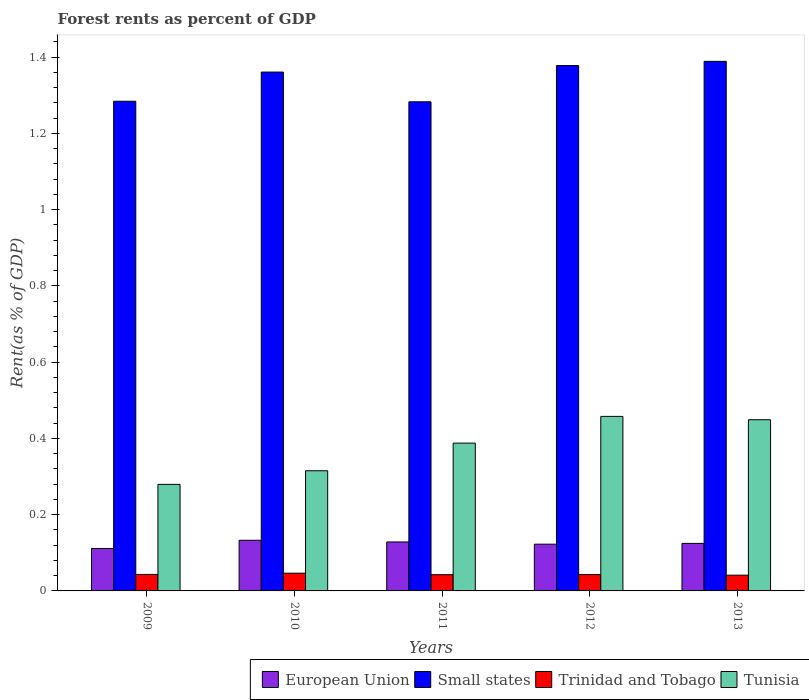How many different coloured bars are there?
Ensure brevity in your answer.  4. How many groups of bars are there?
Your response must be concise. 5. Are the number of bars per tick equal to the number of legend labels?
Provide a succinct answer. Yes. Are the number of bars on each tick of the X-axis equal?
Your response must be concise. Yes. How many bars are there on the 2nd tick from the left?
Ensure brevity in your answer.  4. In how many cases, is the number of bars for a given year not equal to the number of legend labels?
Your response must be concise. 0. What is the forest rent in Trinidad and Tobago in 2010?
Make the answer very short. 0.05. Across all years, what is the maximum forest rent in European Union?
Ensure brevity in your answer.  0.13. Across all years, what is the minimum forest rent in Tunisia?
Offer a very short reply. 0.28. In which year was the forest rent in Tunisia maximum?
Provide a succinct answer. 2012. What is the total forest rent in Tunisia in the graph?
Your answer should be compact. 1.89. What is the difference between the forest rent in Tunisia in 2010 and that in 2013?
Provide a short and direct response. -0.13. What is the difference between the forest rent in Small states in 2011 and the forest rent in European Union in 2010?
Your answer should be very brief. 1.15. What is the average forest rent in Trinidad and Tobago per year?
Keep it short and to the point. 0.04. In the year 2013, what is the difference between the forest rent in Trinidad and Tobago and forest rent in Small states?
Make the answer very short. -1.35. In how many years, is the forest rent in European Union greater than 0.6400000000000001 %?
Your answer should be compact. 0. What is the ratio of the forest rent in Small states in 2009 to that in 2010?
Offer a terse response. 0.94. Is the forest rent in Trinidad and Tobago in 2010 less than that in 2011?
Keep it short and to the point. No. What is the difference between the highest and the second highest forest rent in Trinidad and Tobago?
Provide a succinct answer. 0. What is the difference between the highest and the lowest forest rent in Tunisia?
Your answer should be very brief. 0.18. Is it the case that in every year, the sum of the forest rent in Small states and forest rent in Trinidad and Tobago is greater than the sum of forest rent in Tunisia and forest rent in European Union?
Offer a very short reply. No. What does the 4th bar from the right in 2010 represents?
Ensure brevity in your answer.  European Union. Is it the case that in every year, the sum of the forest rent in Small states and forest rent in Tunisia is greater than the forest rent in Trinidad and Tobago?
Make the answer very short. Yes. Does the graph contain grids?
Give a very brief answer. No. What is the title of the graph?
Provide a succinct answer. Forest rents as percent of GDP. Does "Estonia" appear as one of the legend labels in the graph?
Provide a short and direct response. No. What is the label or title of the X-axis?
Your answer should be compact. Years. What is the label or title of the Y-axis?
Offer a terse response. Rent(as % of GDP). What is the Rent(as % of GDP) in European Union in 2009?
Ensure brevity in your answer.  0.11. What is the Rent(as % of GDP) in Small states in 2009?
Provide a succinct answer. 1.28. What is the Rent(as % of GDP) of Trinidad and Tobago in 2009?
Provide a succinct answer. 0.04. What is the Rent(as % of GDP) in Tunisia in 2009?
Offer a very short reply. 0.28. What is the Rent(as % of GDP) in European Union in 2010?
Offer a very short reply. 0.13. What is the Rent(as % of GDP) in Small states in 2010?
Provide a short and direct response. 1.36. What is the Rent(as % of GDP) in Trinidad and Tobago in 2010?
Ensure brevity in your answer.  0.05. What is the Rent(as % of GDP) in Tunisia in 2010?
Provide a succinct answer. 0.32. What is the Rent(as % of GDP) of European Union in 2011?
Your response must be concise. 0.13. What is the Rent(as % of GDP) in Small states in 2011?
Offer a terse response. 1.28. What is the Rent(as % of GDP) in Trinidad and Tobago in 2011?
Provide a short and direct response. 0.04. What is the Rent(as % of GDP) in Tunisia in 2011?
Offer a terse response. 0.39. What is the Rent(as % of GDP) in European Union in 2012?
Your answer should be compact. 0.12. What is the Rent(as % of GDP) in Small states in 2012?
Give a very brief answer. 1.38. What is the Rent(as % of GDP) of Trinidad and Tobago in 2012?
Ensure brevity in your answer.  0.04. What is the Rent(as % of GDP) of Tunisia in 2012?
Keep it short and to the point. 0.46. What is the Rent(as % of GDP) of European Union in 2013?
Give a very brief answer. 0.12. What is the Rent(as % of GDP) in Small states in 2013?
Your response must be concise. 1.39. What is the Rent(as % of GDP) of Trinidad and Tobago in 2013?
Your response must be concise. 0.04. What is the Rent(as % of GDP) in Tunisia in 2013?
Provide a succinct answer. 0.45. Across all years, what is the maximum Rent(as % of GDP) in European Union?
Your response must be concise. 0.13. Across all years, what is the maximum Rent(as % of GDP) of Small states?
Keep it short and to the point. 1.39. Across all years, what is the maximum Rent(as % of GDP) of Trinidad and Tobago?
Offer a terse response. 0.05. Across all years, what is the maximum Rent(as % of GDP) in Tunisia?
Offer a very short reply. 0.46. Across all years, what is the minimum Rent(as % of GDP) in European Union?
Give a very brief answer. 0.11. Across all years, what is the minimum Rent(as % of GDP) in Small states?
Your response must be concise. 1.28. Across all years, what is the minimum Rent(as % of GDP) of Trinidad and Tobago?
Offer a terse response. 0.04. Across all years, what is the minimum Rent(as % of GDP) in Tunisia?
Provide a succinct answer. 0.28. What is the total Rent(as % of GDP) of European Union in the graph?
Your answer should be compact. 0.62. What is the total Rent(as % of GDP) in Small states in the graph?
Offer a very short reply. 6.7. What is the total Rent(as % of GDP) of Trinidad and Tobago in the graph?
Your response must be concise. 0.22. What is the total Rent(as % of GDP) in Tunisia in the graph?
Give a very brief answer. 1.89. What is the difference between the Rent(as % of GDP) in European Union in 2009 and that in 2010?
Your answer should be compact. -0.02. What is the difference between the Rent(as % of GDP) of Small states in 2009 and that in 2010?
Make the answer very short. -0.08. What is the difference between the Rent(as % of GDP) of Trinidad and Tobago in 2009 and that in 2010?
Offer a very short reply. -0. What is the difference between the Rent(as % of GDP) of Tunisia in 2009 and that in 2010?
Your answer should be very brief. -0.04. What is the difference between the Rent(as % of GDP) in European Union in 2009 and that in 2011?
Provide a short and direct response. -0.02. What is the difference between the Rent(as % of GDP) of Small states in 2009 and that in 2011?
Provide a short and direct response. 0. What is the difference between the Rent(as % of GDP) of Trinidad and Tobago in 2009 and that in 2011?
Make the answer very short. 0. What is the difference between the Rent(as % of GDP) in Tunisia in 2009 and that in 2011?
Offer a terse response. -0.11. What is the difference between the Rent(as % of GDP) of European Union in 2009 and that in 2012?
Ensure brevity in your answer.  -0.01. What is the difference between the Rent(as % of GDP) in Small states in 2009 and that in 2012?
Your answer should be compact. -0.09. What is the difference between the Rent(as % of GDP) of Tunisia in 2009 and that in 2012?
Your answer should be compact. -0.18. What is the difference between the Rent(as % of GDP) of European Union in 2009 and that in 2013?
Offer a terse response. -0.01. What is the difference between the Rent(as % of GDP) of Small states in 2009 and that in 2013?
Ensure brevity in your answer.  -0.1. What is the difference between the Rent(as % of GDP) of Trinidad and Tobago in 2009 and that in 2013?
Your response must be concise. 0. What is the difference between the Rent(as % of GDP) of Tunisia in 2009 and that in 2013?
Provide a short and direct response. -0.17. What is the difference between the Rent(as % of GDP) of European Union in 2010 and that in 2011?
Ensure brevity in your answer.  0. What is the difference between the Rent(as % of GDP) in Small states in 2010 and that in 2011?
Make the answer very short. 0.08. What is the difference between the Rent(as % of GDP) of Trinidad and Tobago in 2010 and that in 2011?
Your answer should be very brief. 0. What is the difference between the Rent(as % of GDP) in Tunisia in 2010 and that in 2011?
Ensure brevity in your answer.  -0.07. What is the difference between the Rent(as % of GDP) of European Union in 2010 and that in 2012?
Ensure brevity in your answer.  0.01. What is the difference between the Rent(as % of GDP) in Small states in 2010 and that in 2012?
Offer a terse response. -0.02. What is the difference between the Rent(as % of GDP) in Trinidad and Tobago in 2010 and that in 2012?
Offer a terse response. 0. What is the difference between the Rent(as % of GDP) in Tunisia in 2010 and that in 2012?
Provide a succinct answer. -0.14. What is the difference between the Rent(as % of GDP) of European Union in 2010 and that in 2013?
Give a very brief answer. 0.01. What is the difference between the Rent(as % of GDP) in Small states in 2010 and that in 2013?
Provide a succinct answer. -0.03. What is the difference between the Rent(as % of GDP) of Trinidad and Tobago in 2010 and that in 2013?
Give a very brief answer. 0.01. What is the difference between the Rent(as % of GDP) in Tunisia in 2010 and that in 2013?
Give a very brief answer. -0.13. What is the difference between the Rent(as % of GDP) in European Union in 2011 and that in 2012?
Offer a terse response. 0.01. What is the difference between the Rent(as % of GDP) of Small states in 2011 and that in 2012?
Your answer should be compact. -0.1. What is the difference between the Rent(as % of GDP) in Trinidad and Tobago in 2011 and that in 2012?
Offer a terse response. -0. What is the difference between the Rent(as % of GDP) in Tunisia in 2011 and that in 2012?
Make the answer very short. -0.07. What is the difference between the Rent(as % of GDP) of European Union in 2011 and that in 2013?
Your answer should be very brief. 0. What is the difference between the Rent(as % of GDP) of Small states in 2011 and that in 2013?
Keep it short and to the point. -0.11. What is the difference between the Rent(as % of GDP) in Trinidad and Tobago in 2011 and that in 2013?
Ensure brevity in your answer.  0. What is the difference between the Rent(as % of GDP) of Tunisia in 2011 and that in 2013?
Provide a short and direct response. -0.06. What is the difference between the Rent(as % of GDP) in European Union in 2012 and that in 2013?
Offer a very short reply. -0. What is the difference between the Rent(as % of GDP) of Small states in 2012 and that in 2013?
Provide a short and direct response. -0.01. What is the difference between the Rent(as % of GDP) of Trinidad and Tobago in 2012 and that in 2013?
Make the answer very short. 0. What is the difference between the Rent(as % of GDP) in Tunisia in 2012 and that in 2013?
Give a very brief answer. 0.01. What is the difference between the Rent(as % of GDP) of European Union in 2009 and the Rent(as % of GDP) of Small states in 2010?
Give a very brief answer. -1.25. What is the difference between the Rent(as % of GDP) of European Union in 2009 and the Rent(as % of GDP) of Trinidad and Tobago in 2010?
Give a very brief answer. 0.06. What is the difference between the Rent(as % of GDP) of European Union in 2009 and the Rent(as % of GDP) of Tunisia in 2010?
Your answer should be compact. -0.2. What is the difference between the Rent(as % of GDP) of Small states in 2009 and the Rent(as % of GDP) of Trinidad and Tobago in 2010?
Give a very brief answer. 1.24. What is the difference between the Rent(as % of GDP) of Small states in 2009 and the Rent(as % of GDP) of Tunisia in 2010?
Provide a succinct answer. 0.97. What is the difference between the Rent(as % of GDP) in Trinidad and Tobago in 2009 and the Rent(as % of GDP) in Tunisia in 2010?
Provide a succinct answer. -0.27. What is the difference between the Rent(as % of GDP) of European Union in 2009 and the Rent(as % of GDP) of Small states in 2011?
Your response must be concise. -1.17. What is the difference between the Rent(as % of GDP) in European Union in 2009 and the Rent(as % of GDP) in Trinidad and Tobago in 2011?
Make the answer very short. 0.07. What is the difference between the Rent(as % of GDP) of European Union in 2009 and the Rent(as % of GDP) of Tunisia in 2011?
Ensure brevity in your answer.  -0.28. What is the difference between the Rent(as % of GDP) in Small states in 2009 and the Rent(as % of GDP) in Trinidad and Tobago in 2011?
Provide a short and direct response. 1.24. What is the difference between the Rent(as % of GDP) in Small states in 2009 and the Rent(as % of GDP) in Tunisia in 2011?
Ensure brevity in your answer.  0.9. What is the difference between the Rent(as % of GDP) of Trinidad and Tobago in 2009 and the Rent(as % of GDP) of Tunisia in 2011?
Provide a succinct answer. -0.34. What is the difference between the Rent(as % of GDP) in European Union in 2009 and the Rent(as % of GDP) in Small states in 2012?
Your answer should be compact. -1.27. What is the difference between the Rent(as % of GDP) in European Union in 2009 and the Rent(as % of GDP) in Trinidad and Tobago in 2012?
Your response must be concise. 0.07. What is the difference between the Rent(as % of GDP) of European Union in 2009 and the Rent(as % of GDP) of Tunisia in 2012?
Provide a succinct answer. -0.35. What is the difference between the Rent(as % of GDP) in Small states in 2009 and the Rent(as % of GDP) in Trinidad and Tobago in 2012?
Offer a terse response. 1.24. What is the difference between the Rent(as % of GDP) in Small states in 2009 and the Rent(as % of GDP) in Tunisia in 2012?
Ensure brevity in your answer.  0.83. What is the difference between the Rent(as % of GDP) in Trinidad and Tobago in 2009 and the Rent(as % of GDP) in Tunisia in 2012?
Make the answer very short. -0.41. What is the difference between the Rent(as % of GDP) of European Union in 2009 and the Rent(as % of GDP) of Small states in 2013?
Make the answer very short. -1.28. What is the difference between the Rent(as % of GDP) of European Union in 2009 and the Rent(as % of GDP) of Trinidad and Tobago in 2013?
Provide a succinct answer. 0.07. What is the difference between the Rent(as % of GDP) in European Union in 2009 and the Rent(as % of GDP) in Tunisia in 2013?
Provide a succinct answer. -0.34. What is the difference between the Rent(as % of GDP) in Small states in 2009 and the Rent(as % of GDP) in Trinidad and Tobago in 2013?
Provide a succinct answer. 1.24. What is the difference between the Rent(as % of GDP) of Small states in 2009 and the Rent(as % of GDP) of Tunisia in 2013?
Your answer should be very brief. 0.84. What is the difference between the Rent(as % of GDP) of Trinidad and Tobago in 2009 and the Rent(as % of GDP) of Tunisia in 2013?
Ensure brevity in your answer.  -0.41. What is the difference between the Rent(as % of GDP) of European Union in 2010 and the Rent(as % of GDP) of Small states in 2011?
Keep it short and to the point. -1.15. What is the difference between the Rent(as % of GDP) in European Union in 2010 and the Rent(as % of GDP) in Trinidad and Tobago in 2011?
Keep it short and to the point. 0.09. What is the difference between the Rent(as % of GDP) of European Union in 2010 and the Rent(as % of GDP) of Tunisia in 2011?
Your answer should be very brief. -0.25. What is the difference between the Rent(as % of GDP) of Small states in 2010 and the Rent(as % of GDP) of Trinidad and Tobago in 2011?
Your answer should be very brief. 1.32. What is the difference between the Rent(as % of GDP) in Small states in 2010 and the Rent(as % of GDP) in Tunisia in 2011?
Your answer should be very brief. 0.97. What is the difference between the Rent(as % of GDP) in Trinidad and Tobago in 2010 and the Rent(as % of GDP) in Tunisia in 2011?
Make the answer very short. -0.34. What is the difference between the Rent(as % of GDP) of European Union in 2010 and the Rent(as % of GDP) of Small states in 2012?
Make the answer very short. -1.25. What is the difference between the Rent(as % of GDP) of European Union in 2010 and the Rent(as % of GDP) of Trinidad and Tobago in 2012?
Offer a terse response. 0.09. What is the difference between the Rent(as % of GDP) of European Union in 2010 and the Rent(as % of GDP) of Tunisia in 2012?
Provide a short and direct response. -0.32. What is the difference between the Rent(as % of GDP) in Small states in 2010 and the Rent(as % of GDP) in Trinidad and Tobago in 2012?
Give a very brief answer. 1.32. What is the difference between the Rent(as % of GDP) in Small states in 2010 and the Rent(as % of GDP) in Tunisia in 2012?
Give a very brief answer. 0.9. What is the difference between the Rent(as % of GDP) in Trinidad and Tobago in 2010 and the Rent(as % of GDP) in Tunisia in 2012?
Your answer should be compact. -0.41. What is the difference between the Rent(as % of GDP) in European Union in 2010 and the Rent(as % of GDP) in Small states in 2013?
Keep it short and to the point. -1.26. What is the difference between the Rent(as % of GDP) in European Union in 2010 and the Rent(as % of GDP) in Trinidad and Tobago in 2013?
Keep it short and to the point. 0.09. What is the difference between the Rent(as % of GDP) in European Union in 2010 and the Rent(as % of GDP) in Tunisia in 2013?
Make the answer very short. -0.32. What is the difference between the Rent(as % of GDP) of Small states in 2010 and the Rent(as % of GDP) of Trinidad and Tobago in 2013?
Your answer should be compact. 1.32. What is the difference between the Rent(as % of GDP) of Small states in 2010 and the Rent(as % of GDP) of Tunisia in 2013?
Your response must be concise. 0.91. What is the difference between the Rent(as % of GDP) in Trinidad and Tobago in 2010 and the Rent(as % of GDP) in Tunisia in 2013?
Offer a very short reply. -0.4. What is the difference between the Rent(as % of GDP) in European Union in 2011 and the Rent(as % of GDP) in Small states in 2012?
Your response must be concise. -1.25. What is the difference between the Rent(as % of GDP) in European Union in 2011 and the Rent(as % of GDP) in Trinidad and Tobago in 2012?
Provide a short and direct response. 0.09. What is the difference between the Rent(as % of GDP) in European Union in 2011 and the Rent(as % of GDP) in Tunisia in 2012?
Give a very brief answer. -0.33. What is the difference between the Rent(as % of GDP) in Small states in 2011 and the Rent(as % of GDP) in Trinidad and Tobago in 2012?
Make the answer very short. 1.24. What is the difference between the Rent(as % of GDP) in Small states in 2011 and the Rent(as % of GDP) in Tunisia in 2012?
Make the answer very short. 0.83. What is the difference between the Rent(as % of GDP) of Trinidad and Tobago in 2011 and the Rent(as % of GDP) of Tunisia in 2012?
Your response must be concise. -0.42. What is the difference between the Rent(as % of GDP) in European Union in 2011 and the Rent(as % of GDP) in Small states in 2013?
Keep it short and to the point. -1.26. What is the difference between the Rent(as % of GDP) of European Union in 2011 and the Rent(as % of GDP) of Trinidad and Tobago in 2013?
Provide a short and direct response. 0.09. What is the difference between the Rent(as % of GDP) of European Union in 2011 and the Rent(as % of GDP) of Tunisia in 2013?
Make the answer very short. -0.32. What is the difference between the Rent(as % of GDP) of Small states in 2011 and the Rent(as % of GDP) of Trinidad and Tobago in 2013?
Ensure brevity in your answer.  1.24. What is the difference between the Rent(as % of GDP) in Small states in 2011 and the Rent(as % of GDP) in Tunisia in 2013?
Offer a very short reply. 0.83. What is the difference between the Rent(as % of GDP) of Trinidad and Tobago in 2011 and the Rent(as % of GDP) of Tunisia in 2013?
Give a very brief answer. -0.41. What is the difference between the Rent(as % of GDP) of European Union in 2012 and the Rent(as % of GDP) of Small states in 2013?
Give a very brief answer. -1.27. What is the difference between the Rent(as % of GDP) of European Union in 2012 and the Rent(as % of GDP) of Trinidad and Tobago in 2013?
Provide a succinct answer. 0.08. What is the difference between the Rent(as % of GDP) in European Union in 2012 and the Rent(as % of GDP) in Tunisia in 2013?
Make the answer very short. -0.33. What is the difference between the Rent(as % of GDP) in Small states in 2012 and the Rent(as % of GDP) in Trinidad and Tobago in 2013?
Make the answer very short. 1.34. What is the difference between the Rent(as % of GDP) of Small states in 2012 and the Rent(as % of GDP) of Tunisia in 2013?
Offer a terse response. 0.93. What is the difference between the Rent(as % of GDP) in Trinidad and Tobago in 2012 and the Rent(as % of GDP) in Tunisia in 2013?
Offer a very short reply. -0.41. What is the average Rent(as % of GDP) in European Union per year?
Keep it short and to the point. 0.12. What is the average Rent(as % of GDP) of Small states per year?
Your answer should be compact. 1.34. What is the average Rent(as % of GDP) of Trinidad and Tobago per year?
Make the answer very short. 0.04. What is the average Rent(as % of GDP) of Tunisia per year?
Offer a very short reply. 0.38. In the year 2009, what is the difference between the Rent(as % of GDP) in European Union and Rent(as % of GDP) in Small states?
Offer a terse response. -1.17. In the year 2009, what is the difference between the Rent(as % of GDP) in European Union and Rent(as % of GDP) in Trinidad and Tobago?
Provide a short and direct response. 0.07. In the year 2009, what is the difference between the Rent(as % of GDP) in European Union and Rent(as % of GDP) in Tunisia?
Your answer should be very brief. -0.17. In the year 2009, what is the difference between the Rent(as % of GDP) in Small states and Rent(as % of GDP) in Trinidad and Tobago?
Your answer should be compact. 1.24. In the year 2009, what is the difference between the Rent(as % of GDP) of Trinidad and Tobago and Rent(as % of GDP) of Tunisia?
Your response must be concise. -0.24. In the year 2010, what is the difference between the Rent(as % of GDP) in European Union and Rent(as % of GDP) in Small states?
Keep it short and to the point. -1.23. In the year 2010, what is the difference between the Rent(as % of GDP) in European Union and Rent(as % of GDP) in Trinidad and Tobago?
Provide a succinct answer. 0.09. In the year 2010, what is the difference between the Rent(as % of GDP) of European Union and Rent(as % of GDP) of Tunisia?
Offer a very short reply. -0.18. In the year 2010, what is the difference between the Rent(as % of GDP) in Small states and Rent(as % of GDP) in Trinidad and Tobago?
Provide a short and direct response. 1.31. In the year 2010, what is the difference between the Rent(as % of GDP) in Small states and Rent(as % of GDP) in Tunisia?
Your answer should be compact. 1.05. In the year 2010, what is the difference between the Rent(as % of GDP) in Trinidad and Tobago and Rent(as % of GDP) in Tunisia?
Provide a succinct answer. -0.27. In the year 2011, what is the difference between the Rent(as % of GDP) of European Union and Rent(as % of GDP) of Small states?
Your response must be concise. -1.15. In the year 2011, what is the difference between the Rent(as % of GDP) of European Union and Rent(as % of GDP) of Trinidad and Tobago?
Give a very brief answer. 0.09. In the year 2011, what is the difference between the Rent(as % of GDP) in European Union and Rent(as % of GDP) in Tunisia?
Ensure brevity in your answer.  -0.26. In the year 2011, what is the difference between the Rent(as % of GDP) in Small states and Rent(as % of GDP) in Trinidad and Tobago?
Provide a succinct answer. 1.24. In the year 2011, what is the difference between the Rent(as % of GDP) in Small states and Rent(as % of GDP) in Tunisia?
Offer a very short reply. 0.9. In the year 2011, what is the difference between the Rent(as % of GDP) in Trinidad and Tobago and Rent(as % of GDP) in Tunisia?
Your response must be concise. -0.35. In the year 2012, what is the difference between the Rent(as % of GDP) in European Union and Rent(as % of GDP) in Small states?
Your response must be concise. -1.26. In the year 2012, what is the difference between the Rent(as % of GDP) of European Union and Rent(as % of GDP) of Trinidad and Tobago?
Your response must be concise. 0.08. In the year 2012, what is the difference between the Rent(as % of GDP) in European Union and Rent(as % of GDP) in Tunisia?
Your answer should be very brief. -0.34. In the year 2012, what is the difference between the Rent(as % of GDP) in Small states and Rent(as % of GDP) in Trinidad and Tobago?
Your answer should be compact. 1.34. In the year 2012, what is the difference between the Rent(as % of GDP) in Small states and Rent(as % of GDP) in Tunisia?
Offer a very short reply. 0.92. In the year 2012, what is the difference between the Rent(as % of GDP) in Trinidad and Tobago and Rent(as % of GDP) in Tunisia?
Your answer should be very brief. -0.41. In the year 2013, what is the difference between the Rent(as % of GDP) in European Union and Rent(as % of GDP) in Small states?
Make the answer very short. -1.26. In the year 2013, what is the difference between the Rent(as % of GDP) in European Union and Rent(as % of GDP) in Trinidad and Tobago?
Keep it short and to the point. 0.08. In the year 2013, what is the difference between the Rent(as % of GDP) of European Union and Rent(as % of GDP) of Tunisia?
Your answer should be very brief. -0.32. In the year 2013, what is the difference between the Rent(as % of GDP) in Small states and Rent(as % of GDP) in Trinidad and Tobago?
Your response must be concise. 1.35. In the year 2013, what is the difference between the Rent(as % of GDP) in Small states and Rent(as % of GDP) in Tunisia?
Provide a short and direct response. 0.94. In the year 2013, what is the difference between the Rent(as % of GDP) in Trinidad and Tobago and Rent(as % of GDP) in Tunisia?
Make the answer very short. -0.41. What is the ratio of the Rent(as % of GDP) of European Union in 2009 to that in 2010?
Offer a terse response. 0.84. What is the ratio of the Rent(as % of GDP) in Small states in 2009 to that in 2010?
Ensure brevity in your answer.  0.94. What is the ratio of the Rent(as % of GDP) of Trinidad and Tobago in 2009 to that in 2010?
Your response must be concise. 0.93. What is the ratio of the Rent(as % of GDP) of Tunisia in 2009 to that in 2010?
Offer a terse response. 0.89. What is the ratio of the Rent(as % of GDP) of European Union in 2009 to that in 2011?
Ensure brevity in your answer.  0.87. What is the ratio of the Rent(as % of GDP) in Trinidad and Tobago in 2009 to that in 2011?
Ensure brevity in your answer.  1.02. What is the ratio of the Rent(as % of GDP) in Tunisia in 2009 to that in 2011?
Offer a terse response. 0.72. What is the ratio of the Rent(as % of GDP) of European Union in 2009 to that in 2012?
Ensure brevity in your answer.  0.91. What is the ratio of the Rent(as % of GDP) of Small states in 2009 to that in 2012?
Make the answer very short. 0.93. What is the ratio of the Rent(as % of GDP) in Trinidad and Tobago in 2009 to that in 2012?
Offer a terse response. 1.01. What is the ratio of the Rent(as % of GDP) of Tunisia in 2009 to that in 2012?
Offer a terse response. 0.61. What is the ratio of the Rent(as % of GDP) in European Union in 2009 to that in 2013?
Your answer should be very brief. 0.89. What is the ratio of the Rent(as % of GDP) in Small states in 2009 to that in 2013?
Give a very brief answer. 0.92. What is the ratio of the Rent(as % of GDP) of Trinidad and Tobago in 2009 to that in 2013?
Provide a short and direct response. 1.05. What is the ratio of the Rent(as % of GDP) of Tunisia in 2009 to that in 2013?
Your answer should be compact. 0.62. What is the ratio of the Rent(as % of GDP) in European Union in 2010 to that in 2011?
Provide a short and direct response. 1.03. What is the ratio of the Rent(as % of GDP) of Small states in 2010 to that in 2011?
Provide a short and direct response. 1.06. What is the ratio of the Rent(as % of GDP) in Trinidad and Tobago in 2010 to that in 2011?
Ensure brevity in your answer.  1.09. What is the ratio of the Rent(as % of GDP) in Tunisia in 2010 to that in 2011?
Your answer should be compact. 0.81. What is the ratio of the Rent(as % of GDP) in European Union in 2010 to that in 2012?
Make the answer very short. 1.08. What is the ratio of the Rent(as % of GDP) in Small states in 2010 to that in 2012?
Keep it short and to the point. 0.99. What is the ratio of the Rent(as % of GDP) in Trinidad and Tobago in 2010 to that in 2012?
Make the answer very short. 1.08. What is the ratio of the Rent(as % of GDP) in Tunisia in 2010 to that in 2012?
Provide a short and direct response. 0.69. What is the ratio of the Rent(as % of GDP) of European Union in 2010 to that in 2013?
Your response must be concise. 1.07. What is the ratio of the Rent(as % of GDP) in Small states in 2010 to that in 2013?
Give a very brief answer. 0.98. What is the ratio of the Rent(as % of GDP) in Trinidad and Tobago in 2010 to that in 2013?
Offer a very short reply. 1.13. What is the ratio of the Rent(as % of GDP) of Tunisia in 2010 to that in 2013?
Give a very brief answer. 0.7. What is the ratio of the Rent(as % of GDP) of European Union in 2011 to that in 2012?
Offer a terse response. 1.05. What is the ratio of the Rent(as % of GDP) of Small states in 2011 to that in 2012?
Your answer should be compact. 0.93. What is the ratio of the Rent(as % of GDP) in Tunisia in 2011 to that in 2012?
Give a very brief answer. 0.85. What is the ratio of the Rent(as % of GDP) in European Union in 2011 to that in 2013?
Ensure brevity in your answer.  1.03. What is the ratio of the Rent(as % of GDP) of Small states in 2011 to that in 2013?
Your answer should be very brief. 0.92. What is the ratio of the Rent(as % of GDP) in Trinidad and Tobago in 2011 to that in 2013?
Your answer should be compact. 1.03. What is the ratio of the Rent(as % of GDP) in Tunisia in 2011 to that in 2013?
Your answer should be compact. 0.86. What is the ratio of the Rent(as % of GDP) in European Union in 2012 to that in 2013?
Make the answer very short. 0.98. What is the ratio of the Rent(as % of GDP) in Trinidad and Tobago in 2012 to that in 2013?
Your answer should be very brief. 1.04. What is the ratio of the Rent(as % of GDP) of Tunisia in 2012 to that in 2013?
Provide a succinct answer. 1.02. What is the difference between the highest and the second highest Rent(as % of GDP) of European Union?
Your answer should be compact. 0. What is the difference between the highest and the second highest Rent(as % of GDP) in Small states?
Your answer should be compact. 0.01. What is the difference between the highest and the second highest Rent(as % of GDP) in Trinidad and Tobago?
Ensure brevity in your answer.  0. What is the difference between the highest and the second highest Rent(as % of GDP) of Tunisia?
Make the answer very short. 0.01. What is the difference between the highest and the lowest Rent(as % of GDP) of European Union?
Provide a succinct answer. 0.02. What is the difference between the highest and the lowest Rent(as % of GDP) of Small states?
Keep it short and to the point. 0.11. What is the difference between the highest and the lowest Rent(as % of GDP) in Trinidad and Tobago?
Provide a succinct answer. 0.01. What is the difference between the highest and the lowest Rent(as % of GDP) of Tunisia?
Your answer should be very brief. 0.18. 